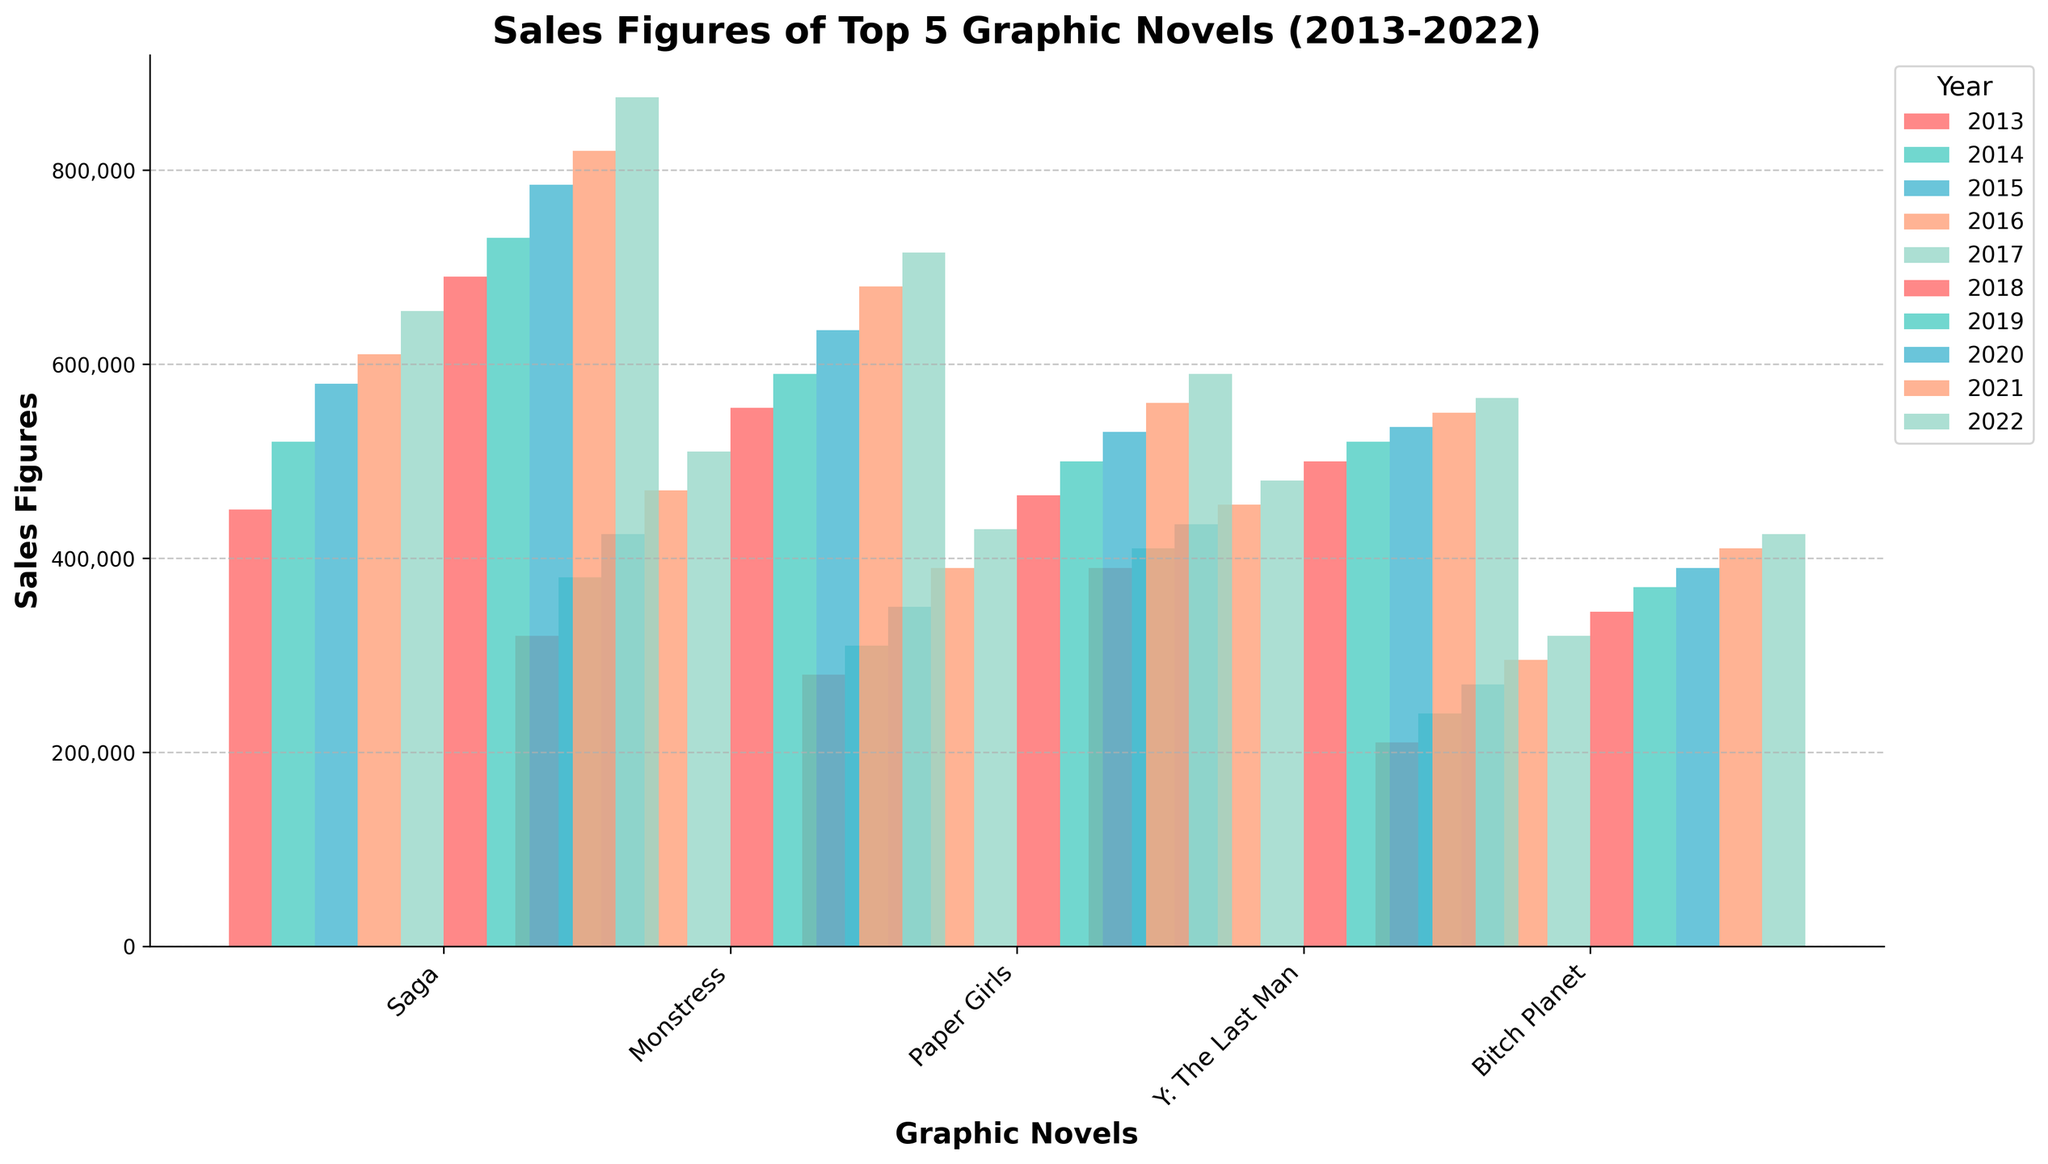What's the best-selling graphic novel in 2022? To find the best-selling graphic novel in 2022, look for the tallest bar in the 2022 group. "Saga" has the tallest bar.
Answer: Saga Which graphic novel had the largest sales increase from 2013 to 2022? To determine which novel had the largest sales increase, calculate the difference between 2022 and 2013 sales for each novel. "Saga" increased from 450,000 to 875,000, an increase of 425,000.
Answer: Saga How do the sales figures for "Paper Girls" and "Bitch Planet" in 2020 compare? Compare the heights of the 2020 bars for "Paper Girls" and "Bitch Planet". "Paper Girls" appears higher with 530,000 compared to "Bitch Planet" with 390,000.
Answer: "Paper Girls" has higher sales Which year saw the highest sales for "Monstress"? Identify the bar with the greatest height in the sequence for "Monstress" and note the corresponding year, which is 2022.
Answer: 2022 What is the total sales figure for "Y: The Last Man" over the decade? Sum the sales figures from 2013 to 2022 for "Y: The Last Man": 390,000 + 410,000 + 435,000 + 455,000 + 480,000 + 500,000 + 520,000 + 535,000 + 550,000 + 565,000.
Answer: 4,840,000 In which year did "Bitch Planet" see its highest sales growth? Calculate the year-over-year difference and identify the year with the largest increase. From 2013 to 2014, sales increased by 30,000 (240,000 - 210,000), which is the highest increment.
Answer: 2014 Which graphic novel consistently increased in sales every year? Look for the novel with bars consistently increasing every year from 2013 to 2022. Both "Saga" and "Monstress" show a consistent yearly increase.
Answer: Saga, Monstress How much more did "Saga" sell than "Paper Girls" in 2017? Determine the sales for "Saga" (655,000) and "Paper Girls" (430,000) in 2017, then subtract Paper Girls' sales from Saga's sales: 655,000 - 430,000 = 225,000.
Answer: 225,000 What's the difference between the highest and lowest sales figures in 2015? Identify the highest (Saga: 580,000) and lowest (Bitch Planet: 270,000) sales figures in 2015 and subtract the lowest from the highest: 580,000 - 270,000 = 310,000.
Answer: 310,000 